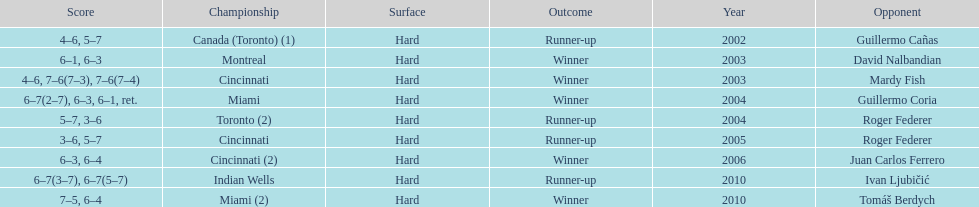What was the highest number of consecutive wins? 3. 